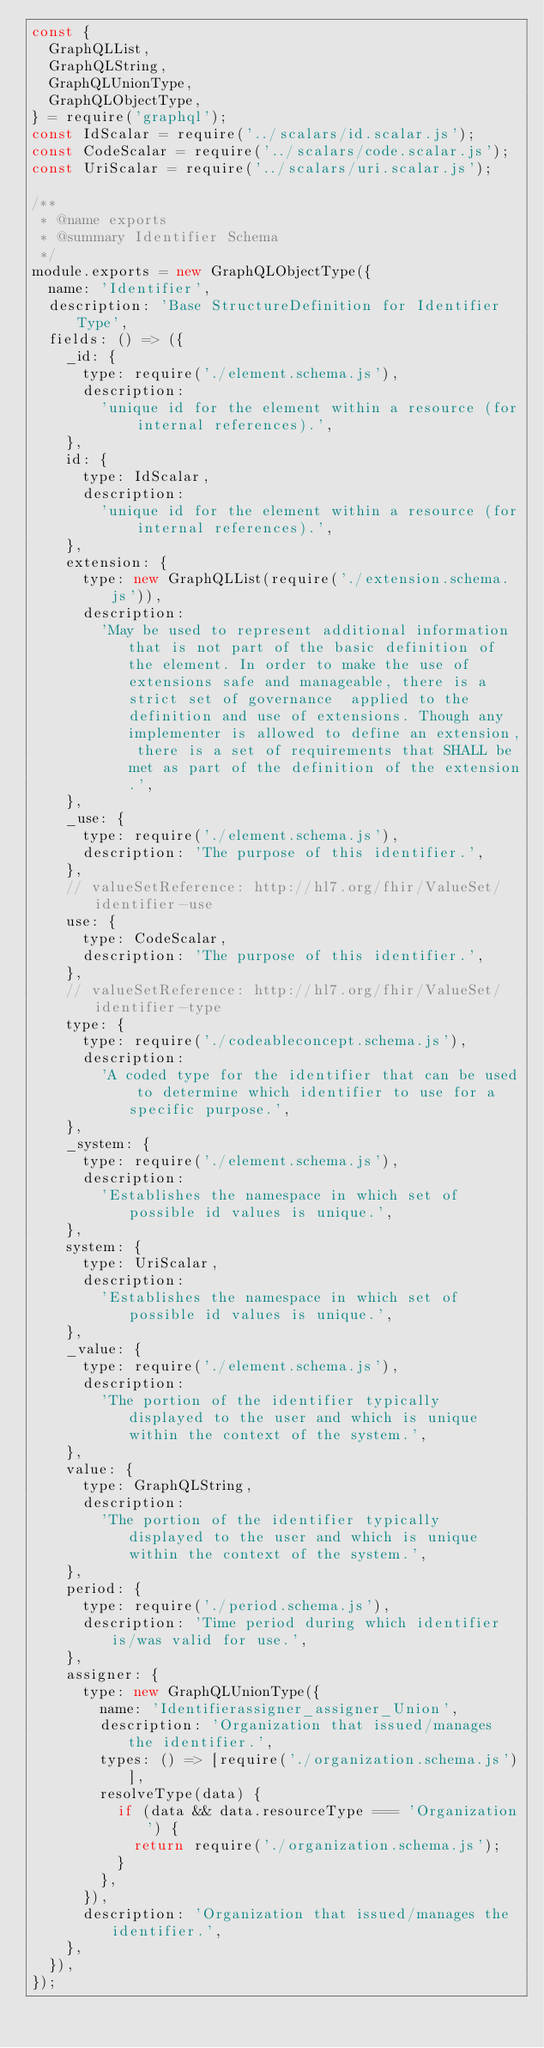Convert code to text. <code><loc_0><loc_0><loc_500><loc_500><_JavaScript_>const {
	GraphQLList,
	GraphQLString,
	GraphQLUnionType,
	GraphQLObjectType,
} = require('graphql');
const IdScalar = require('../scalars/id.scalar.js');
const CodeScalar = require('../scalars/code.scalar.js');
const UriScalar = require('../scalars/uri.scalar.js');

/**
 * @name exports
 * @summary Identifier Schema
 */
module.exports = new GraphQLObjectType({
	name: 'Identifier',
	description: 'Base StructureDefinition for Identifier Type',
	fields: () => ({
		_id: {
			type: require('./element.schema.js'),
			description:
				'unique id for the element within a resource (for internal references).',
		},
		id: {
			type: IdScalar,
			description:
				'unique id for the element within a resource (for internal references).',
		},
		extension: {
			type: new GraphQLList(require('./extension.schema.js')),
			description:
				'May be used to represent additional information that is not part of the basic definition of the element. In order to make the use of extensions safe and manageable, there is a strict set of governance  applied to the definition and use of extensions. Though any implementer is allowed to define an extension, there is a set of requirements that SHALL be met as part of the definition of the extension.',
		},
		_use: {
			type: require('./element.schema.js'),
			description: 'The purpose of this identifier.',
		},
		// valueSetReference: http://hl7.org/fhir/ValueSet/identifier-use
		use: {
			type: CodeScalar,
			description: 'The purpose of this identifier.',
		},
		// valueSetReference: http://hl7.org/fhir/ValueSet/identifier-type
		type: {
			type: require('./codeableconcept.schema.js'),
			description:
				'A coded type for the identifier that can be used to determine which identifier to use for a specific purpose.',
		},
		_system: {
			type: require('./element.schema.js'),
			description:
				'Establishes the namespace in which set of possible id values is unique.',
		},
		system: {
			type: UriScalar,
			description:
				'Establishes the namespace in which set of possible id values is unique.',
		},
		_value: {
			type: require('./element.schema.js'),
			description:
				'The portion of the identifier typically displayed to the user and which is unique within the context of the system.',
		},
		value: {
			type: GraphQLString,
			description:
				'The portion of the identifier typically displayed to the user and which is unique within the context of the system.',
		},
		period: {
			type: require('./period.schema.js'),
			description: 'Time period during which identifier is/was valid for use.',
		},
		assigner: {
			type: new GraphQLUnionType({
				name: 'Identifierassigner_assigner_Union',
				description: 'Organization that issued/manages the identifier.',
				types: () => [require('./organization.schema.js')],
				resolveType(data) {
					if (data && data.resourceType === 'Organization') {
						return require('./organization.schema.js');
					}
				},
			}),
			description: 'Organization that issued/manages the identifier.',
		},
	}),
});
</code> 